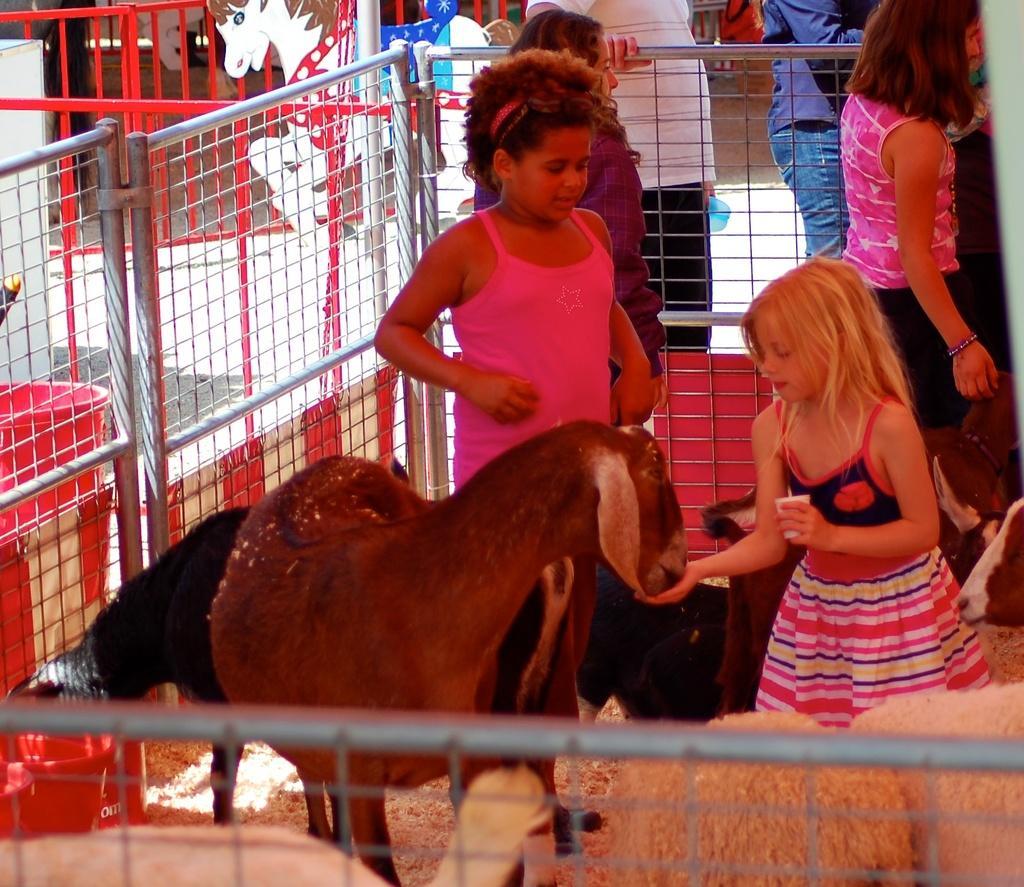Can you describe this image briefly? In this picture I can see few goats and sheep and I can see a girl feeding a goat with her hand and I can see few people standing and I can see a metal fence. 